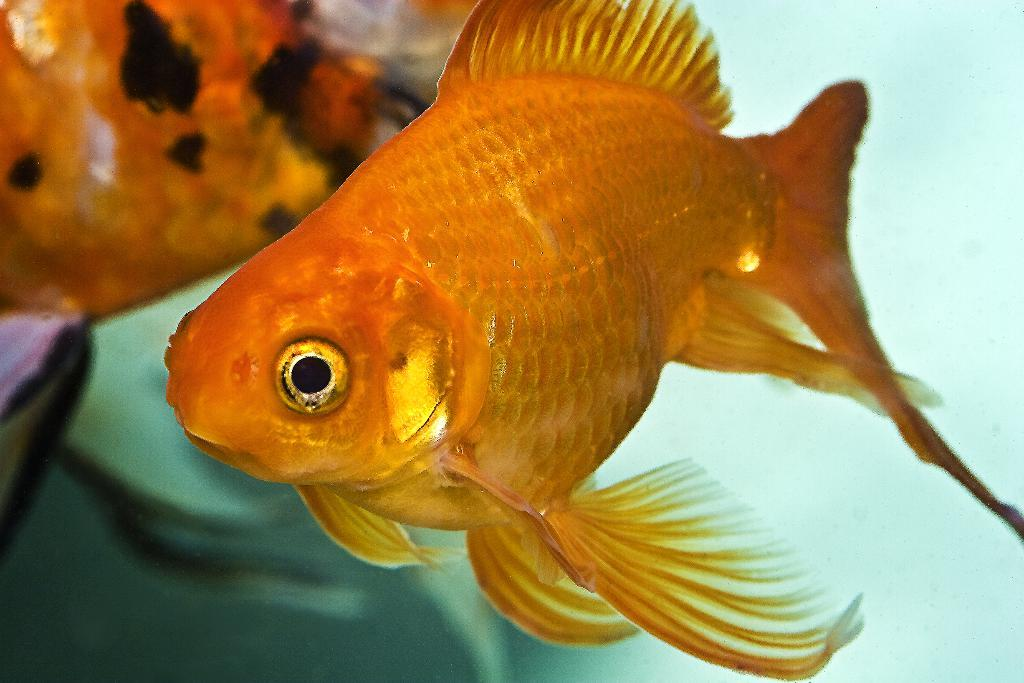What is the main feature of the image? There is a water body in the image. What can be seen in the water body? There are fishes visible in the image. How much was the payment for the copy of the nose in the image? There is no payment, copy, or nose present in the image. 